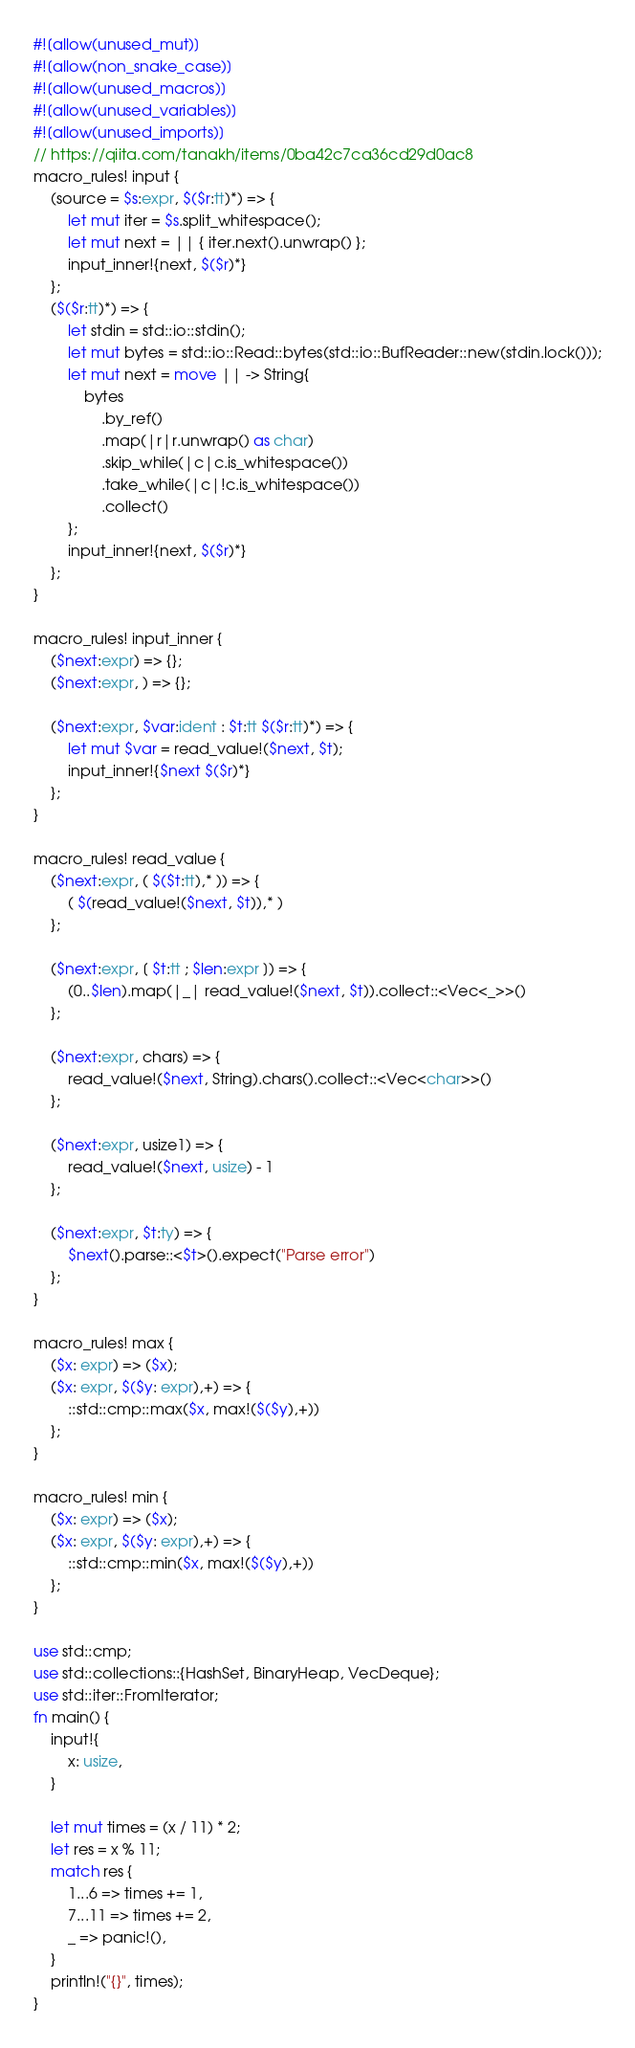<code> <loc_0><loc_0><loc_500><loc_500><_Rust_>#![allow(unused_mut)]
#![allow(non_snake_case)]
#![allow(unused_macros)]
#![allow(unused_variables)]
#![allow(unused_imports)]
// https://qiita.com/tanakh/items/0ba42c7ca36cd29d0ac8
macro_rules! input {
    (source = $s:expr, $($r:tt)*) => {
        let mut iter = $s.split_whitespace();
        let mut next = || { iter.next().unwrap() };
        input_inner!{next, $($r)*}
    };
    ($($r:tt)*) => {
        let stdin = std::io::stdin();
        let mut bytes = std::io::Read::bytes(std::io::BufReader::new(stdin.lock()));
        let mut next = move || -> String{
            bytes
                .by_ref()
                .map(|r|r.unwrap() as char)
                .skip_while(|c|c.is_whitespace())
                .take_while(|c|!c.is_whitespace())
                .collect()
        };
        input_inner!{next, $($r)*}
    };
}

macro_rules! input_inner {
    ($next:expr) => {};
    ($next:expr, ) => {};

    ($next:expr, $var:ident : $t:tt $($r:tt)*) => {
        let mut $var = read_value!($next, $t);
        input_inner!{$next $($r)*}
    };
}

macro_rules! read_value {
    ($next:expr, ( $($t:tt),* )) => {
        ( $(read_value!($next, $t)),* )
    };

    ($next:expr, [ $t:tt ; $len:expr ]) => {
        (0..$len).map(|_| read_value!($next, $t)).collect::<Vec<_>>()
    };

    ($next:expr, chars) => {
        read_value!($next, String).chars().collect::<Vec<char>>()
    };

    ($next:expr, usize1) => {
        read_value!($next, usize) - 1
    };

    ($next:expr, $t:ty) => {
        $next().parse::<$t>().expect("Parse error")
    };
}

macro_rules! max {
    ($x: expr) => ($x);
    ($x: expr, $($y: expr),+) => {
        ::std::cmp::max($x, max!($($y),+))
    };
}

macro_rules! min {
    ($x: expr) => ($x);
    ($x: expr, $($y: expr),+) => {
        ::std::cmp::min($x, max!($($y),+))
    };
}

use std::cmp;
use std::collections::{HashSet, BinaryHeap, VecDeque};
use std::iter::FromIterator;
fn main() {
    input!{
        x: usize,
    }

    let mut times = (x / 11) * 2;
    let res = x % 11;
    match res {
        1...6 => times += 1,
        7...11 => times += 2,
        _ => panic!(),
    }
    println!("{}", times);
}</code> 